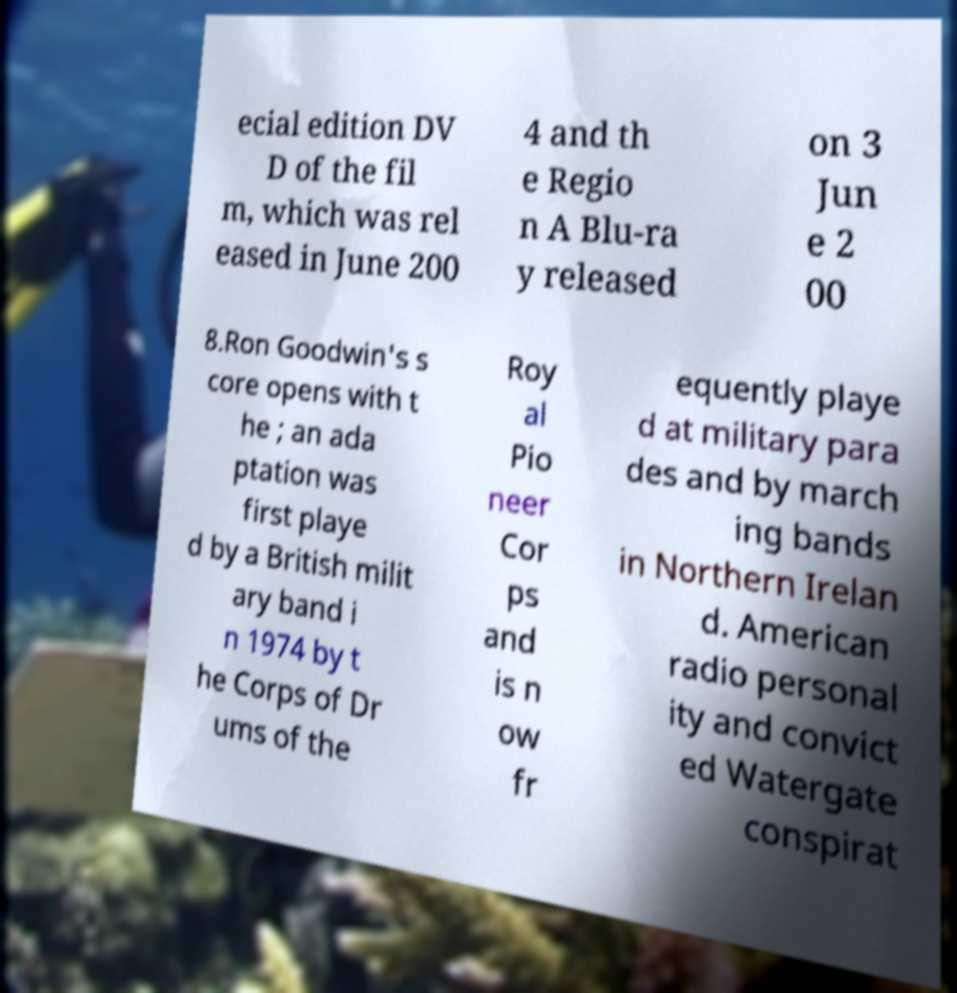Can you accurately transcribe the text from the provided image for me? ecial edition DV D of the fil m, which was rel eased in June 200 4 and th e Regio n A Blu-ra y released on 3 Jun e 2 00 8.Ron Goodwin's s core opens with t he ; an ada ptation was first playe d by a British milit ary band i n 1974 by t he Corps of Dr ums of the Roy al Pio neer Cor ps and is n ow fr equently playe d at military para des and by march ing bands in Northern Irelan d. American radio personal ity and convict ed Watergate conspirat 